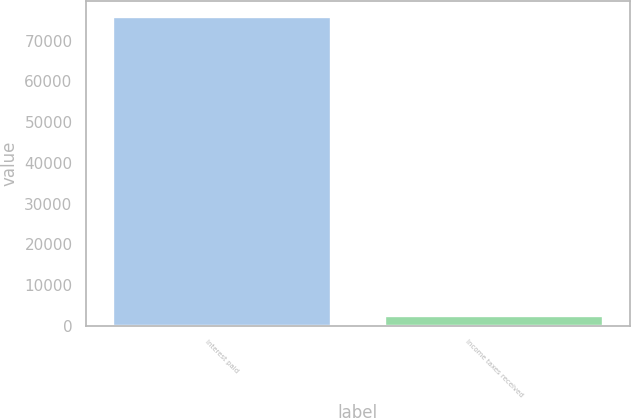<chart> <loc_0><loc_0><loc_500><loc_500><bar_chart><fcel>Interest paid<fcel>Income taxes received<nl><fcel>75909<fcel>2379<nl></chart> 